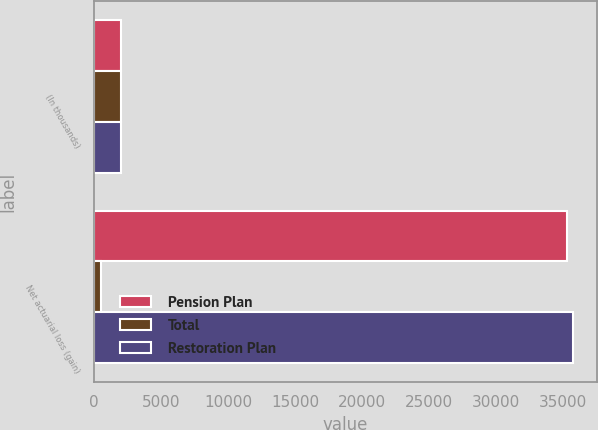Convert chart. <chart><loc_0><loc_0><loc_500><loc_500><stacked_bar_chart><ecel><fcel>(In thousands)<fcel>Net actuarial loss (gain)<nl><fcel>Pension Plan<fcel>2012<fcel>35315<nl><fcel>Total<fcel>2012<fcel>471<nl><fcel>Restoration Plan<fcel>2012<fcel>35786<nl></chart> 